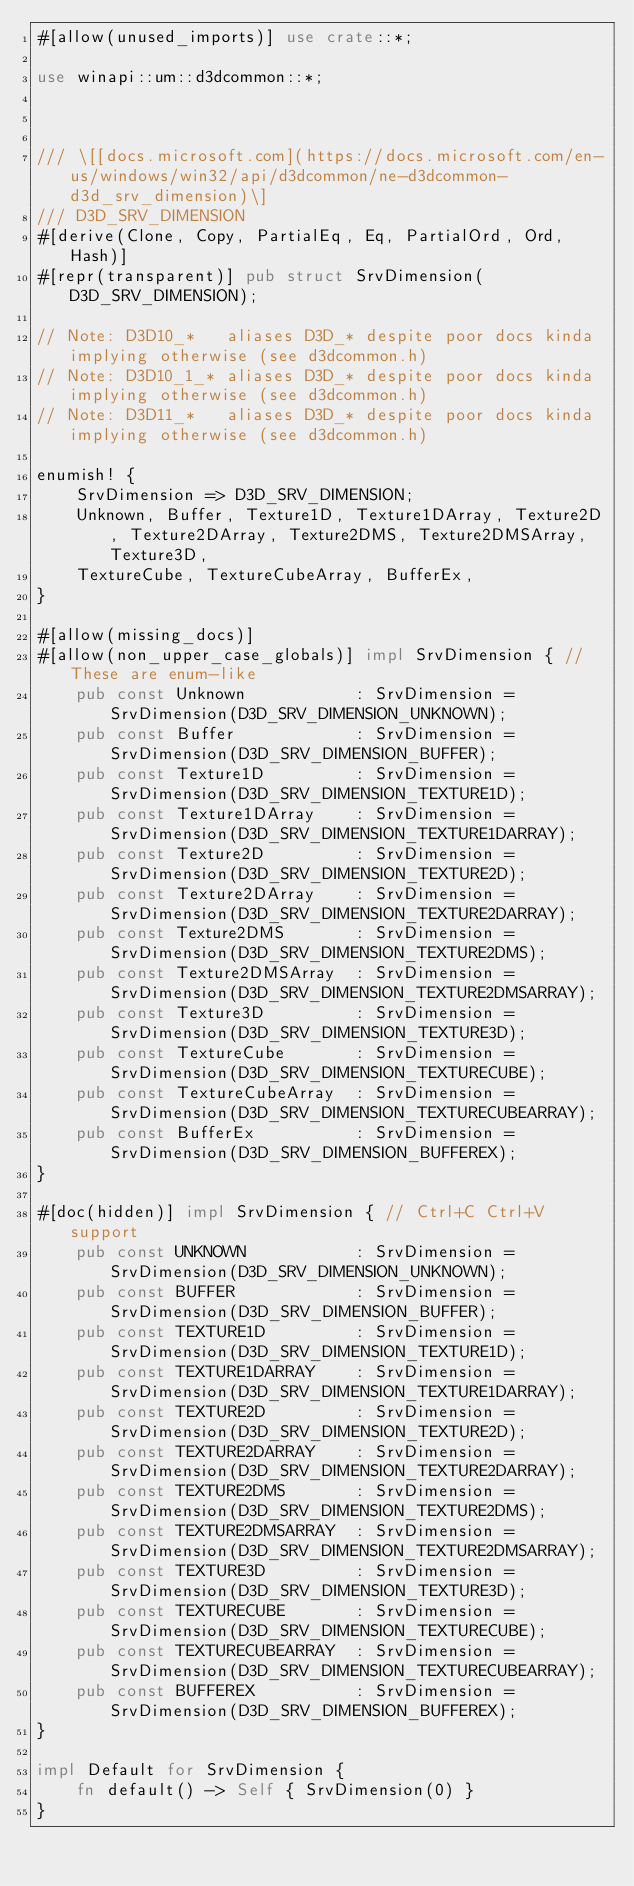Convert code to text. <code><loc_0><loc_0><loc_500><loc_500><_Rust_>#[allow(unused_imports)] use crate::*;

use winapi::um::d3dcommon::*;



/// \[[docs.microsoft.com](https://docs.microsoft.com/en-us/windows/win32/api/d3dcommon/ne-d3dcommon-d3d_srv_dimension)\]
/// D3D_SRV_DIMENSION
#[derive(Clone, Copy, PartialEq, Eq, PartialOrd, Ord, Hash)]
#[repr(transparent)] pub struct SrvDimension(D3D_SRV_DIMENSION);

// Note: D3D10_*   aliases D3D_* despite poor docs kinda implying otherwise (see d3dcommon.h)
// Note: D3D10_1_* aliases D3D_* despite poor docs kinda implying otherwise (see d3dcommon.h)
// Note: D3D11_*   aliases D3D_* despite poor docs kinda implying otherwise (see d3dcommon.h)

enumish! {
    SrvDimension => D3D_SRV_DIMENSION;
    Unknown, Buffer, Texture1D, Texture1DArray, Texture2D, Texture2DArray, Texture2DMS, Texture2DMSArray, Texture3D,
    TextureCube, TextureCubeArray, BufferEx,
}

#[allow(missing_docs)]
#[allow(non_upper_case_globals)] impl SrvDimension { // These are enum-like
    pub const Unknown           : SrvDimension = SrvDimension(D3D_SRV_DIMENSION_UNKNOWN);
    pub const Buffer            : SrvDimension = SrvDimension(D3D_SRV_DIMENSION_BUFFER);
    pub const Texture1D         : SrvDimension = SrvDimension(D3D_SRV_DIMENSION_TEXTURE1D);
    pub const Texture1DArray    : SrvDimension = SrvDimension(D3D_SRV_DIMENSION_TEXTURE1DARRAY);
    pub const Texture2D         : SrvDimension = SrvDimension(D3D_SRV_DIMENSION_TEXTURE2D);
    pub const Texture2DArray    : SrvDimension = SrvDimension(D3D_SRV_DIMENSION_TEXTURE2DARRAY);
    pub const Texture2DMS       : SrvDimension = SrvDimension(D3D_SRV_DIMENSION_TEXTURE2DMS);
    pub const Texture2DMSArray  : SrvDimension = SrvDimension(D3D_SRV_DIMENSION_TEXTURE2DMSARRAY);
    pub const Texture3D         : SrvDimension = SrvDimension(D3D_SRV_DIMENSION_TEXTURE3D);
    pub const TextureCube       : SrvDimension = SrvDimension(D3D_SRV_DIMENSION_TEXTURECUBE);
    pub const TextureCubeArray  : SrvDimension = SrvDimension(D3D_SRV_DIMENSION_TEXTURECUBEARRAY);
    pub const BufferEx          : SrvDimension = SrvDimension(D3D_SRV_DIMENSION_BUFFEREX);
}

#[doc(hidden)] impl SrvDimension { // Ctrl+C Ctrl+V support
    pub const UNKNOWN           : SrvDimension = SrvDimension(D3D_SRV_DIMENSION_UNKNOWN);
    pub const BUFFER            : SrvDimension = SrvDimension(D3D_SRV_DIMENSION_BUFFER);
    pub const TEXTURE1D         : SrvDimension = SrvDimension(D3D_SRV_DIMENSION_TEXTURE1D);
    pub const TEXTURE1DARRAY    : SrvDimension = SrvDimension(D3D_SRV_DIMENSION_TEXTURE1DARRAY);
    pub const TEXTURE2D         : SrvDimension = SrvDimension(D3D_SRV_DIMENSION_TEXTURE2D);
    pub const TEXTURE2DARRAY    : SrvDimension = SrvDimension(D3D_SRV_DIMENSION_TEXTURE2DARRAY);
    pub const TEXTURE2DMS       : SrvDimension = SrvDimension(D3D_SRV_DIMENSION_TEXTURE2DMS);
    pub const TEXTURE2DMSARRAY  : SrvDimension = SrvDimension(D3D_SRV_DIMENSION_TEXTURE2DMSARRAY);
    pub const TEXTURE3D         : SrvDimension = SrvDimension(D3D_SRV_DIMENSION_TEXTURE3D);
    pub const TEXTURECUBE       : SrvDimension = SrvDimension(D3D_SRV_DIMENSION_TEXTURECUBE);
    pub const TEXTURECUBEARRAY  : SrvDimension = SrvDimension(D3D_SRV_DIMENSION_TEXTURECUBEARRAY);
    pub const BUFFEREX          : SrvDimension = SrvDimension(D3D_SRV_DIMENSION_BUFFEREX);
}

impl Default for SrvDimension {
    fn default() -> Self { SrvDimension(0) }
}
</code> 